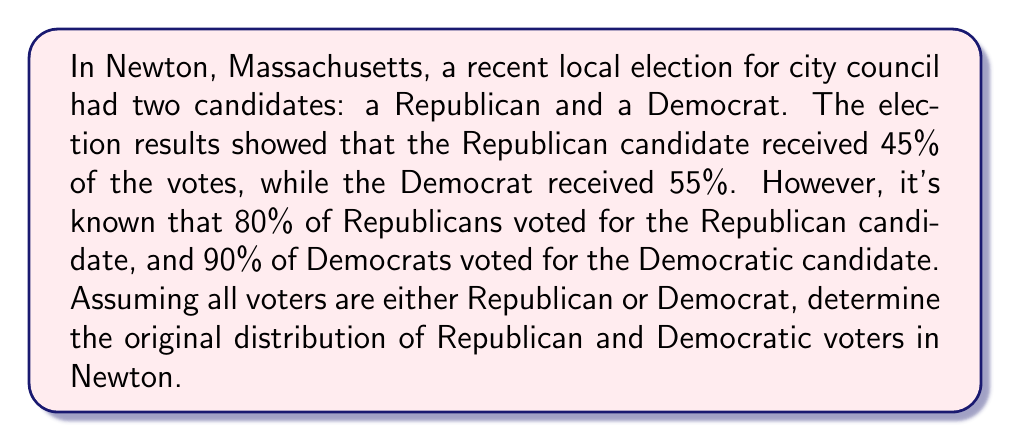Give your solution to this math problem. Let's approach this step-by-step using the given information:

1. Let $x$ be the fraction of Republican voters in the original population.
2. Then, $(1-x)$ is the fraction of Democratic voters.

3. We can set up an equation based on the Republican candidate's vote share:
   $$ 0.8x + 0.1(1-x) = 0.45 $$

   This equation states that 80% of Republicans (0.8x) plus 10% of Democrats (0.1(1-x)) voted for the Republican candidate, resulting in 45% of the total vote.

4. Let's simplify the equation:
   $$ 0.8x + 0.1 - 0.1x = 0.45 $$
   $$ 0.7x + 0.1 = 0.45 $$
   $$ 0.7x = 0.35 $$

5. Solve for $x$:
   $$ x = \frac{0.35}{0.7} = 0.5 $$

6. Therefore, the original population was 50% Republican and 50% Democratic.

7. To verify, we can check the Democratic vote:
   $$ 0.2x + 0.9(1-x) = 0.2(0.5) + 0.9(0.5) = 0.1 + 0.45 = 0.55 $$
   This matches the given result of 55% for the Democratic candidate.
Answer: 50% Republican, 50% Democrat 